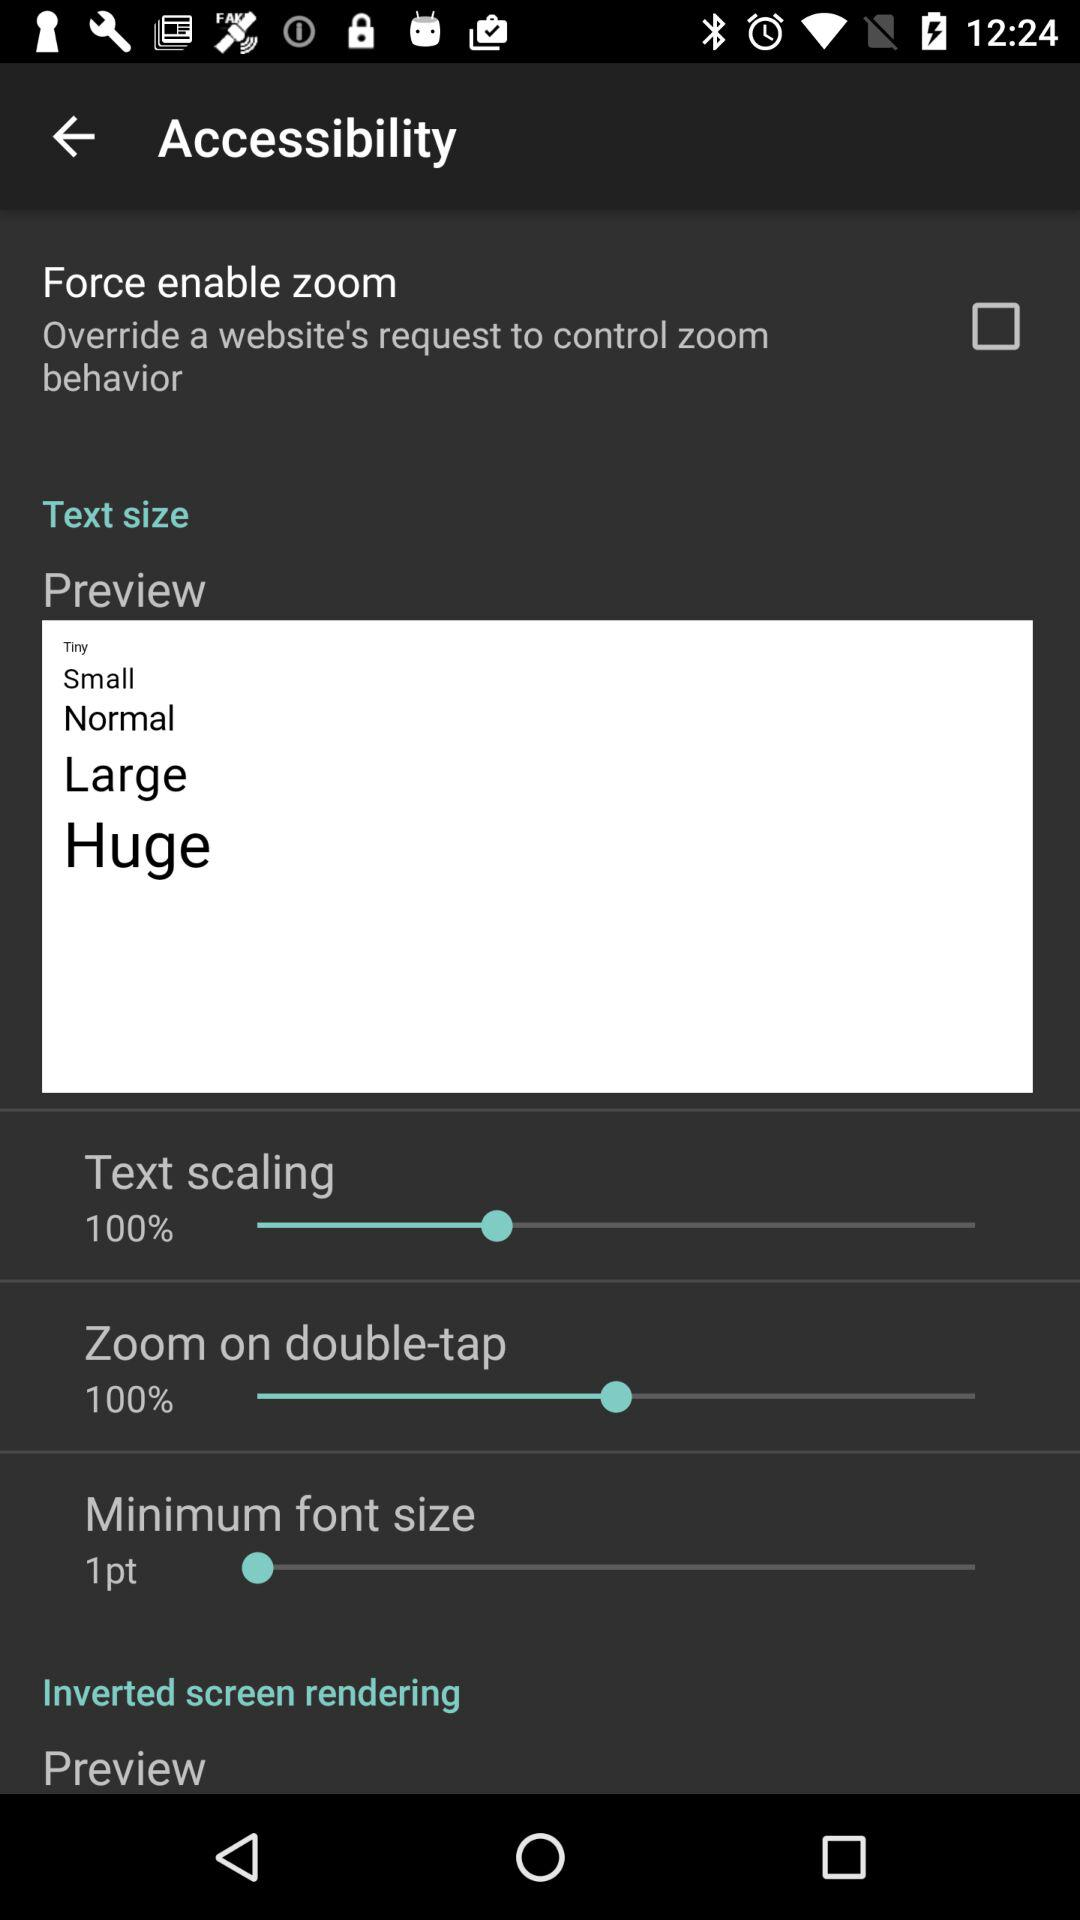What is the selected minimum font size? The selected minimum font size is 1 point. 